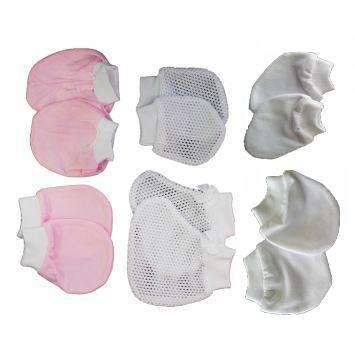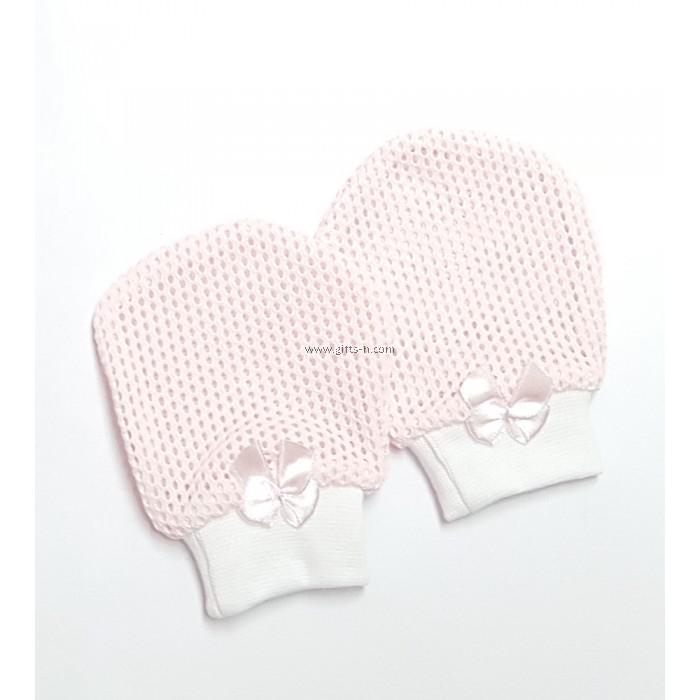The first image is the image on the left, the second image is the image on the right. Evaluate the accuracy of this statement regarding the images: "The left and right image contains a total of four mittens and two bootees.". Is it true? Answer yes or no. No. The first image is the image on the left, the second image is the image on the right. Evaluate the accuracy of this statement regarding the images: "The combined images include three paired items, and one paired item features black-and-white eye shapes.". Is it true? Answer yes or no. No. 